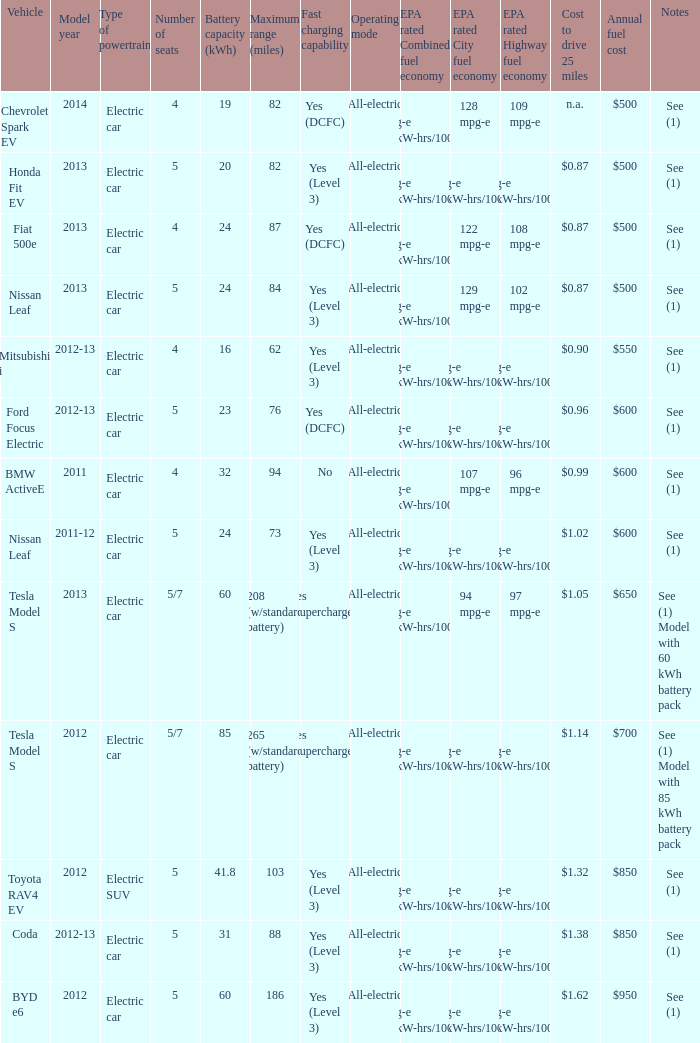What vehicle has an epa highway fuel economy of 109 mpg-e? Chevrolet Spark EV. 